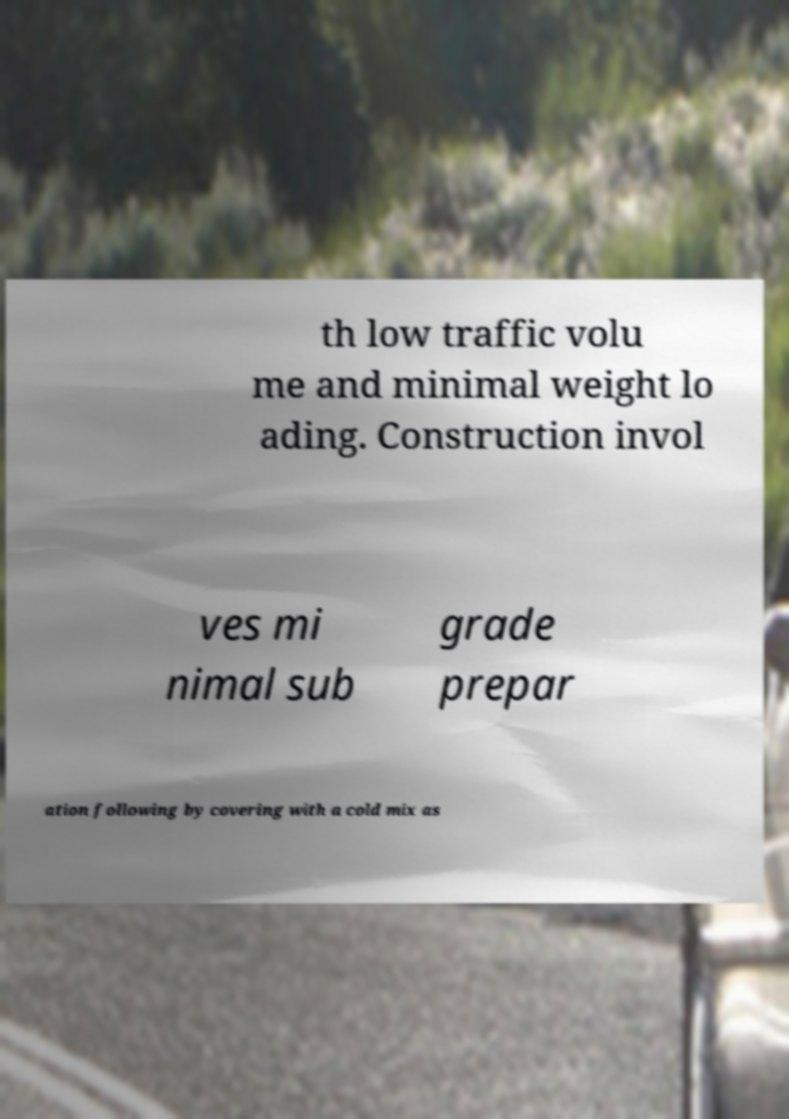There's text embedded in this image that I need extracted. Can you transcribe it verbatim? th low traffic volu me and minimal weight lo ading. Construction invol ves mi nimal sub grade prepar ation following by covering with a cold mix as 